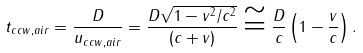<formula> <loc_0><loc_0><loc_500><loc_500>t _ { c c w , a i r } = { \frac { D } { { u _ { c c w , a i r } } } } = { \frac { { D \sqrt { 1 - v ^ { 2 } / c ^ { 2 } } } } { ( c + v ) } } \cong { \frac { D } { c } } \left ( { 1 - { \frac { v } { c } } } \right ) .</formula> 